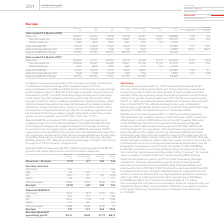From Vodafone Group Plc's financial document, Which countries does the Adjusted EBITDA comprise of? The document contains multiple relevant values: Germany, Italy, UK, Spain, Other Europe, Europe. From the document: "Service revenue Germany 2.6 – – 2.6 Italy 1.0 0.2 – 1.2 UK (8.1) 0.1 4.5 (3.5) Spain 1.8 0.3 – 2.1 Other Europe (19.6) 22.9 (0.4) 2.9 Europe Service r..." Also, What countries does the Service Revenue include? The document contains multiple relevant values: Germany, Italy, UK, Spain, Other Europe, Europe. From the document: "Service revenue Germany 2.6 – – 2.6 Italy 1.0 0.2 – 1.2 UK (8.1) 0.1 4.5 (3.5) Spain 1.8 0.3 – 2.1 Other Europe (19.6) 22.9 (0.4) 2.9 Europe Service r..." Also, What is the reported change in revenue - europe? According to the financial document, (1.9) (percentage). The relevant text states: "Organic* change % Revenue – Europe (1.9) 4.1 0.8 3.0..." Additionally, Between Germany and Italy, which one has a higher organic change? According to the financial document, Germany. The relevant text states: "Service revenue Germany 2.6 – – 2.6 Italy 1.0 0.2 – 1.2 UK (8.1) 0.1 4.5 (3.5) Spain 1.8 0.3 – 2.1 Other Europe (19.6) 22.9..." Also, can you calculate: How many percent of organic change in Europe adjusted operating profit is the organic change in Italy EBITDA? Based on the calculation: 4.6/86.3, the result is 5.33 (percentage). This is based on the information: "Europe adjusted operating profit 53.2 34.8 (1.7) 86.3 TDA Germany 10.9 (0.1) (0.1) 10.7 Italy 4.5 0.1 – 4.6 UK 45.4 (1.2) 7. 6 51.8 Spain 4.4 0.6 – 5.0 Other Europe (18.8) 26.8 (0.3) 7.7 Europe 7.3 5...." The key data points involved are: 4.6, 86.3. Additionally, Between Germany and Italy, which has higher reported change in adjusted EBITDA? According to the financial document, Germany. The relevant text states: "Service revenue Germany 2.6 – – 2.6 Italy 1.0 0.2 – 1.2 UK (8.1) 0.1 4.5 (3.5) Spain 1.8 0.3 – 2.1 Other Europe (19.6) 22.9..." 